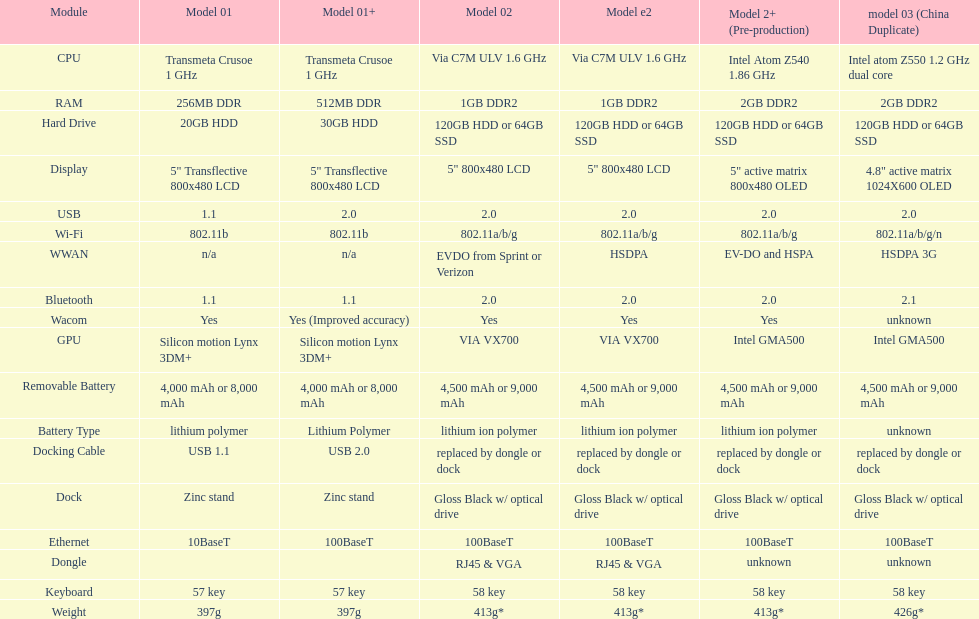What is the overall count of elements present in the diagram? 18. 